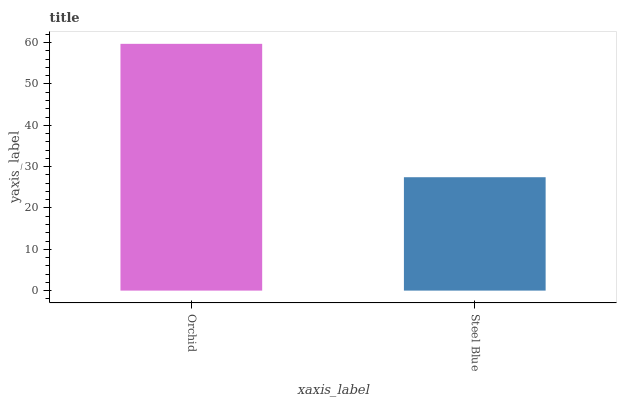Is Steel Blue the minimum?
Answer yes or no. Yes. Is Orchid the maximum?
Answer yes or no. Yes. Is Steel Blue the maximum?
Answer yes or no. No. Is Orchid greater than Steel Blue?
Answer yes or no. Yes. Is Steel Blue less than Orchid?
Answer yes or no. Yes. Is Steel Blue greater than Orchid?
Answer yes or no. No. Is Orchid less than Steel Blue?
Answer yes or no. No. Is Orchid the high median?
Answer yes or no. Yes. Is Steel Blue the low median?
Answer yes or no. Yes. Is Steel Blue the high median?
Answer yes or no. No. Is Orchid the low median?
Answer yes or no. No. 